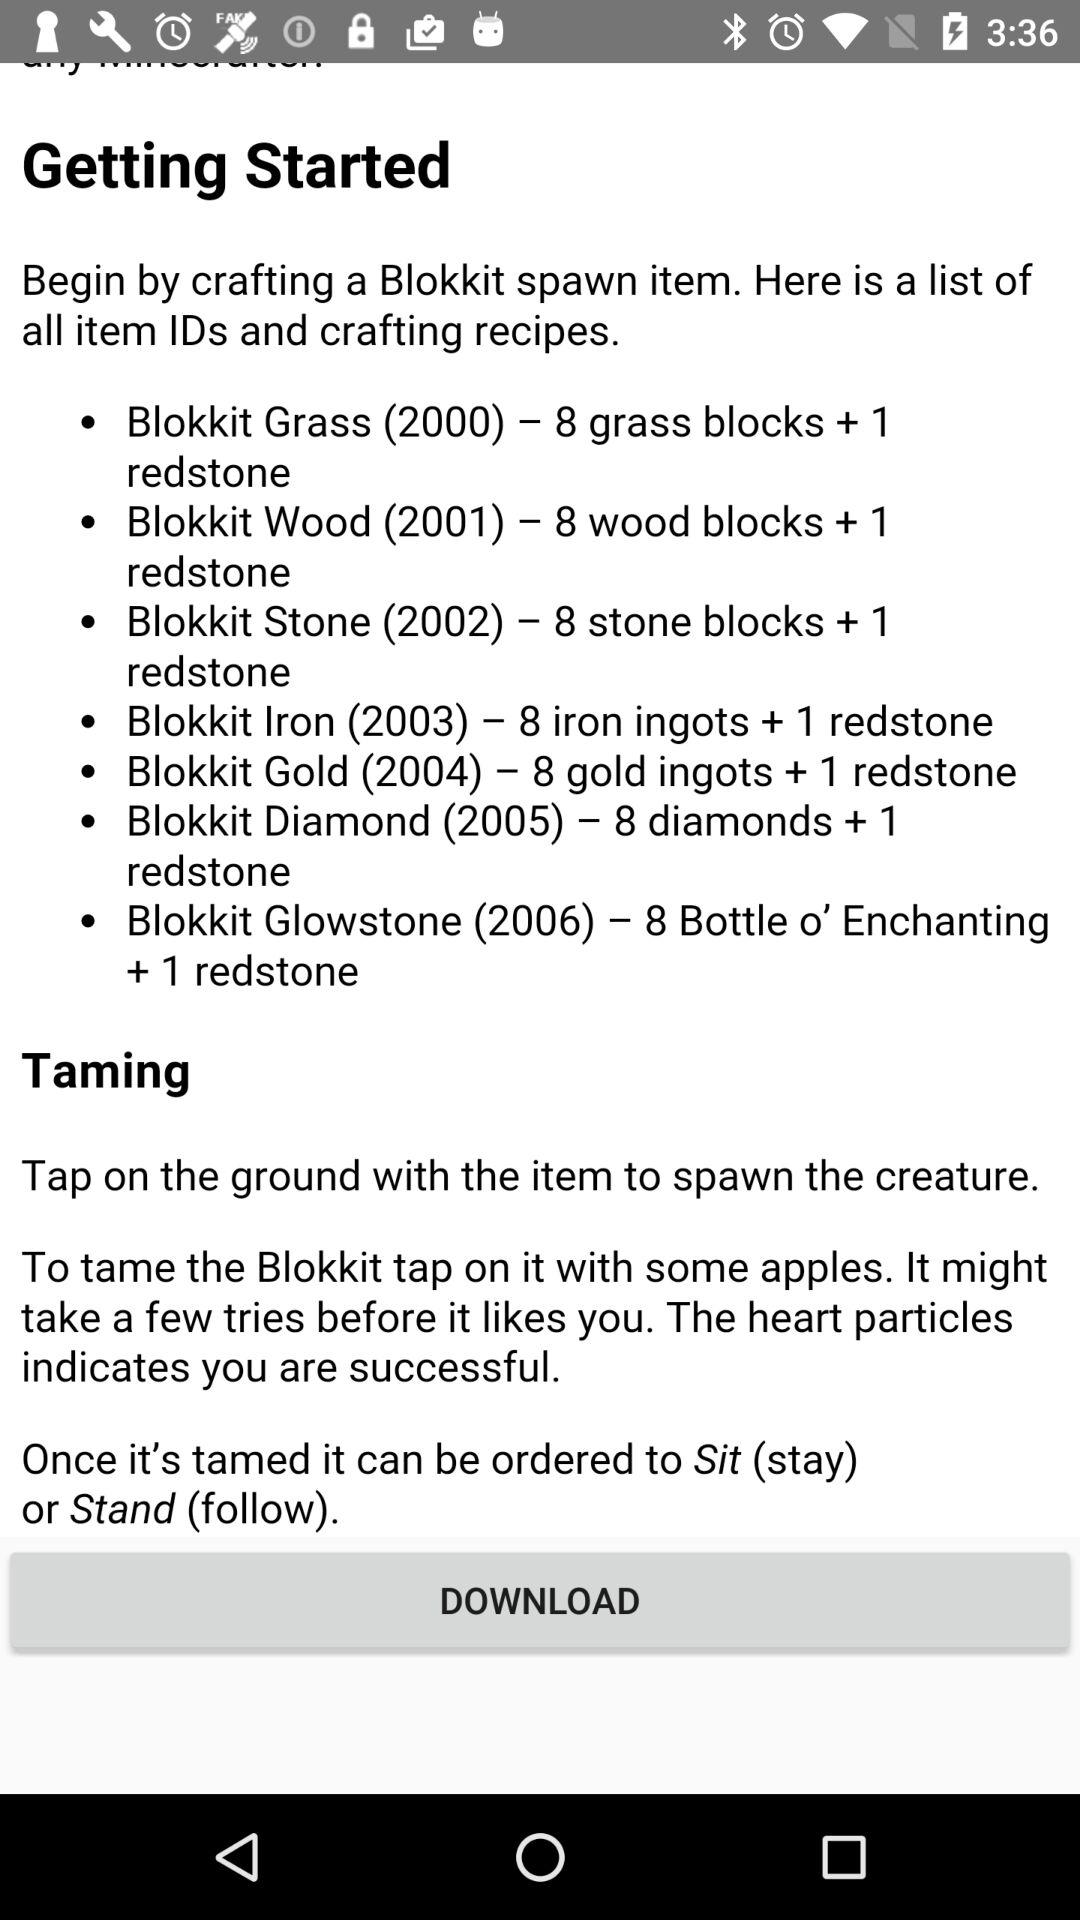How to getting started?
When the provided information is insufficient, respond with <no answer>. <no answer> 